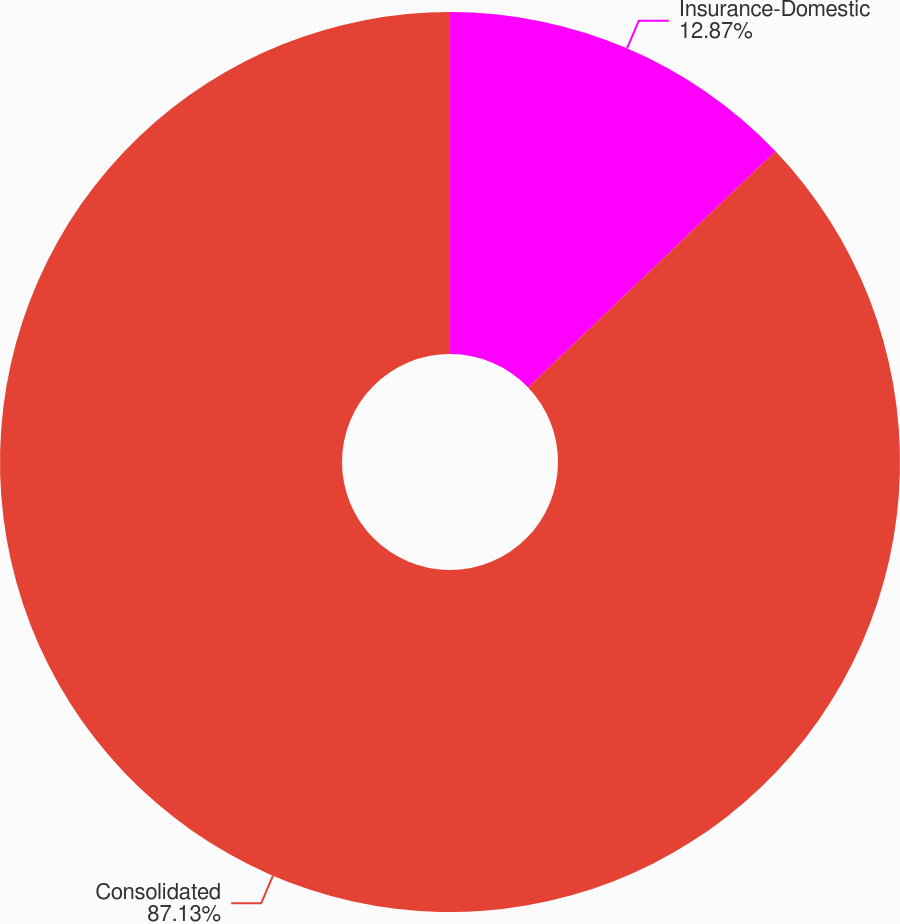<chart> <loc_0><loc_0><loc_500><loc_500><pie_chart><fcel>Insurance-Domestic<fcel>Consolidated<nl><fcel>12.87%<fcel>87.13%<nl></chart> 